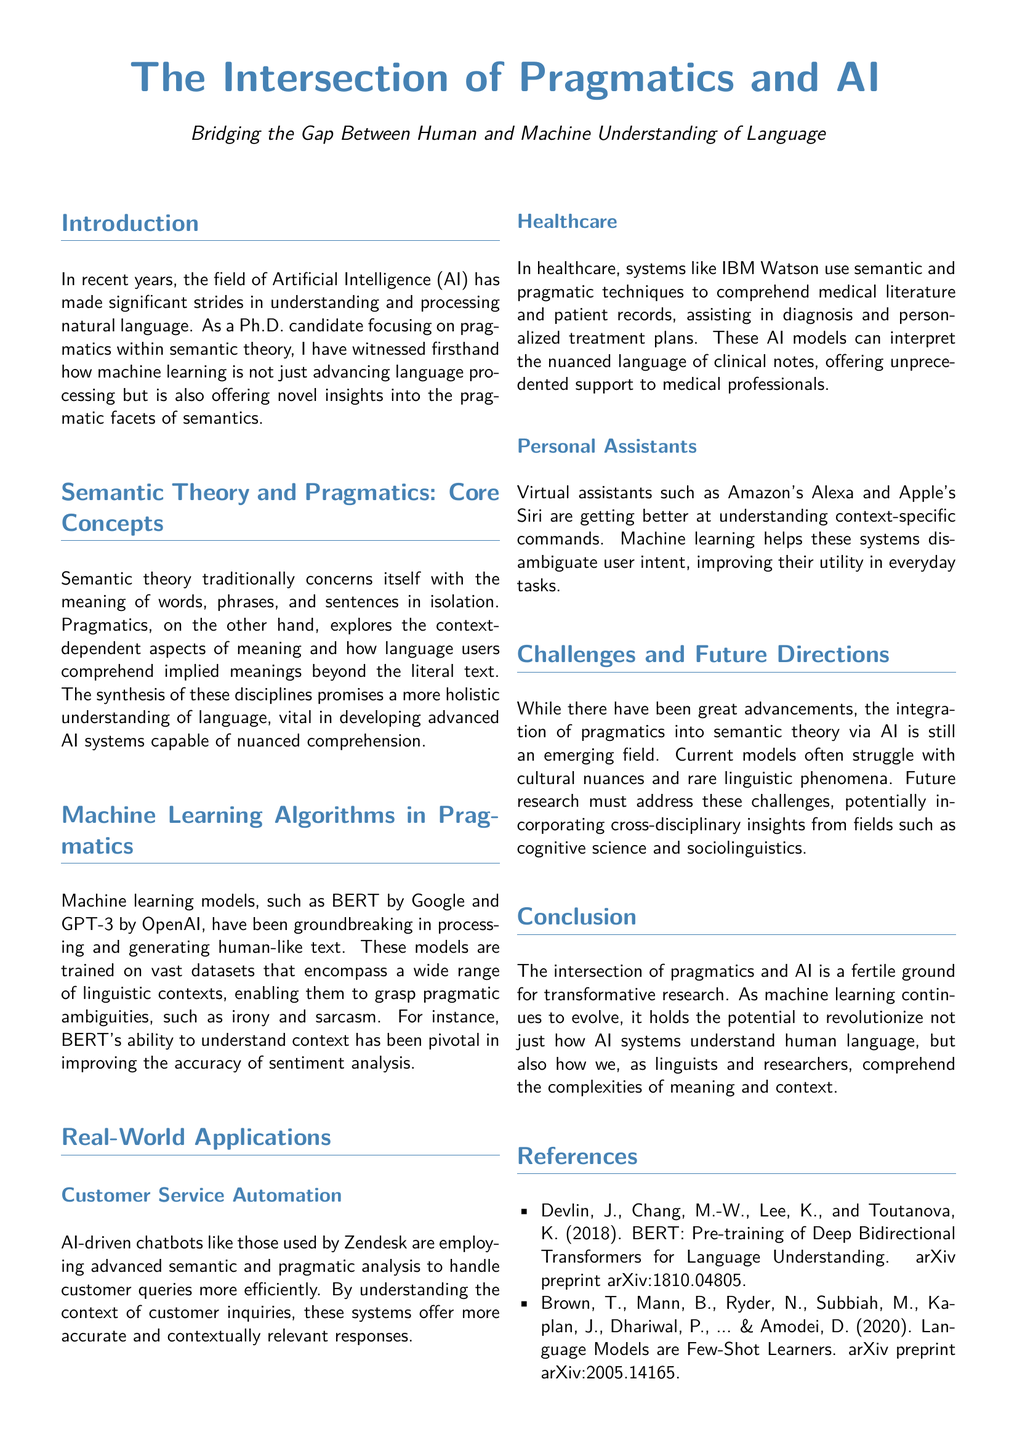What is the title of the document? The title of the document is prominently displayed at the top of the first page.
Answer: The Intersection of Pragmatics and AI Who developed BERT? The document mentions BERT's development within the context of machine learning models.
Answer: Google What are the names of two virtual assistants mentioned? The document lists two specific virtual assistants used as examples.
Answer: Amazon's Alexa and Apple's Siri In which domain is IBM Watson mentioned? The document discusses a specific application of AI in the context of a professional field.
Answer: Healthcare What is one challenge of integrating pragmatics into semantic theory via AI? The document highlights a specific difficulty related to cultural understanding.
Answer: Cultural nuances What is the focus of the introduction section? The introduction provides a specific context about advancements in AI related to language.
Answer: Understanding and processing natural language What does GPT-3 represent? The document references this machine learning model by name and its significance.
Answer: A machine learning model List one of the references mentioned. The reference section contains a number of academic works cited in the document.
Answer: Devlin, J., Chang, M.-W., Lee, K., and Toutanova, K. (2018). BERT: Pre-training of Deep Bidirectional Transformers for Language Understanding 